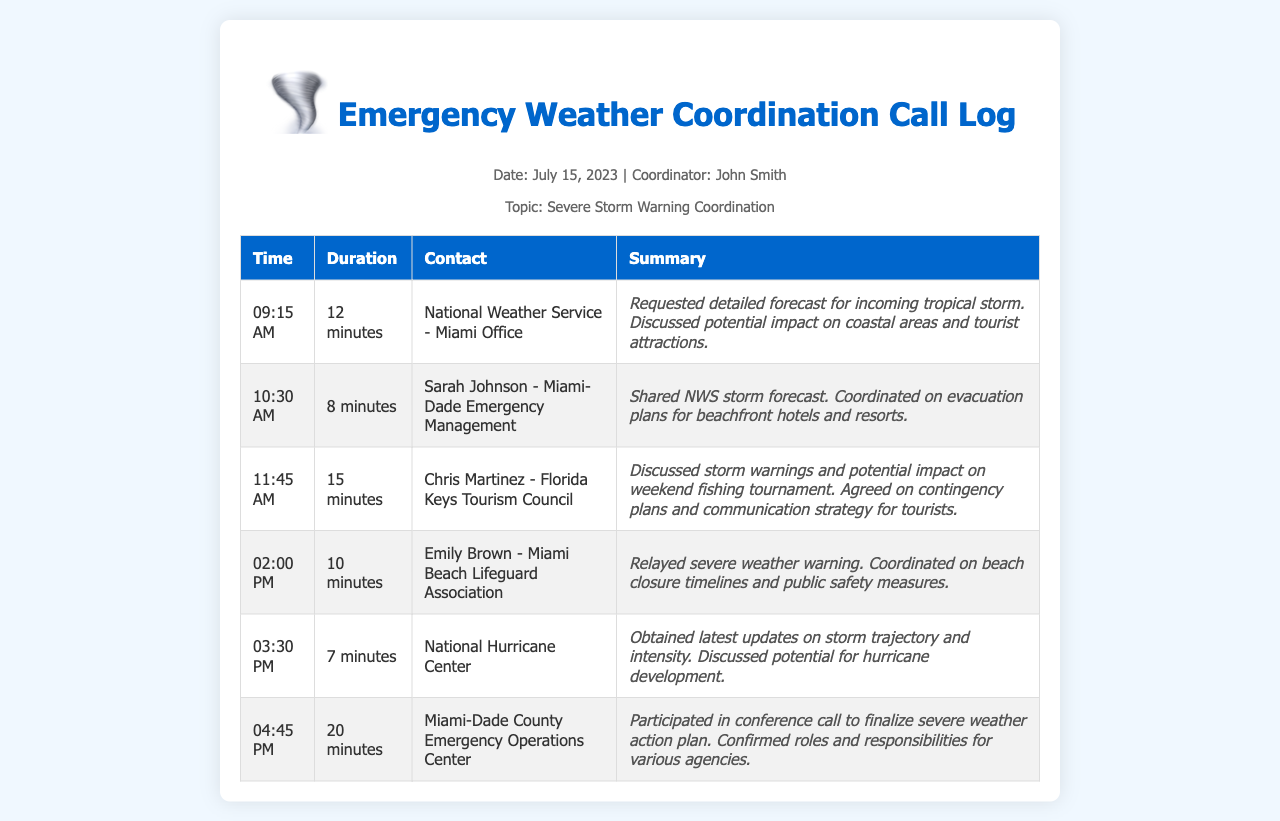what time did the call with the National Weather Service occur? The time of the call with the National Weather Service is listed in the call log.
Answer: 09:15 AM how long was the call with Sarah Johnson? The duration of the call with Sarah Johnson is detailed in the document.
Answer: 8 minutes who was contacted at 11:45 AM? The log provides the names and organizations of the contacts for each call.
Answer: Chris Martinez - Florida Keys Tourism Council what was discussed during the 02:00 PM call? The summary of the 02:00 PM call outlines the topics that were covered.
Answer: Relayed severe weather warning how many agencies were confirmed their roles in the 04:45 PM conference call? The document mentions that roles and responsibilities were confirmed for various agencies during the call.
Answer: Multiple agencies what was the main concern in the call with Chris Martinez? The summary of the conversation provides insight into the primary topic of concern during the call.
Answer: Impact on weekend fishing tournament who coordinated on evacuation plans for beachfront hotels? The call logs specify the contacts and their purposes during the calls.
Answer: Sarah Johnson - Miami-Dade Emergency Management 